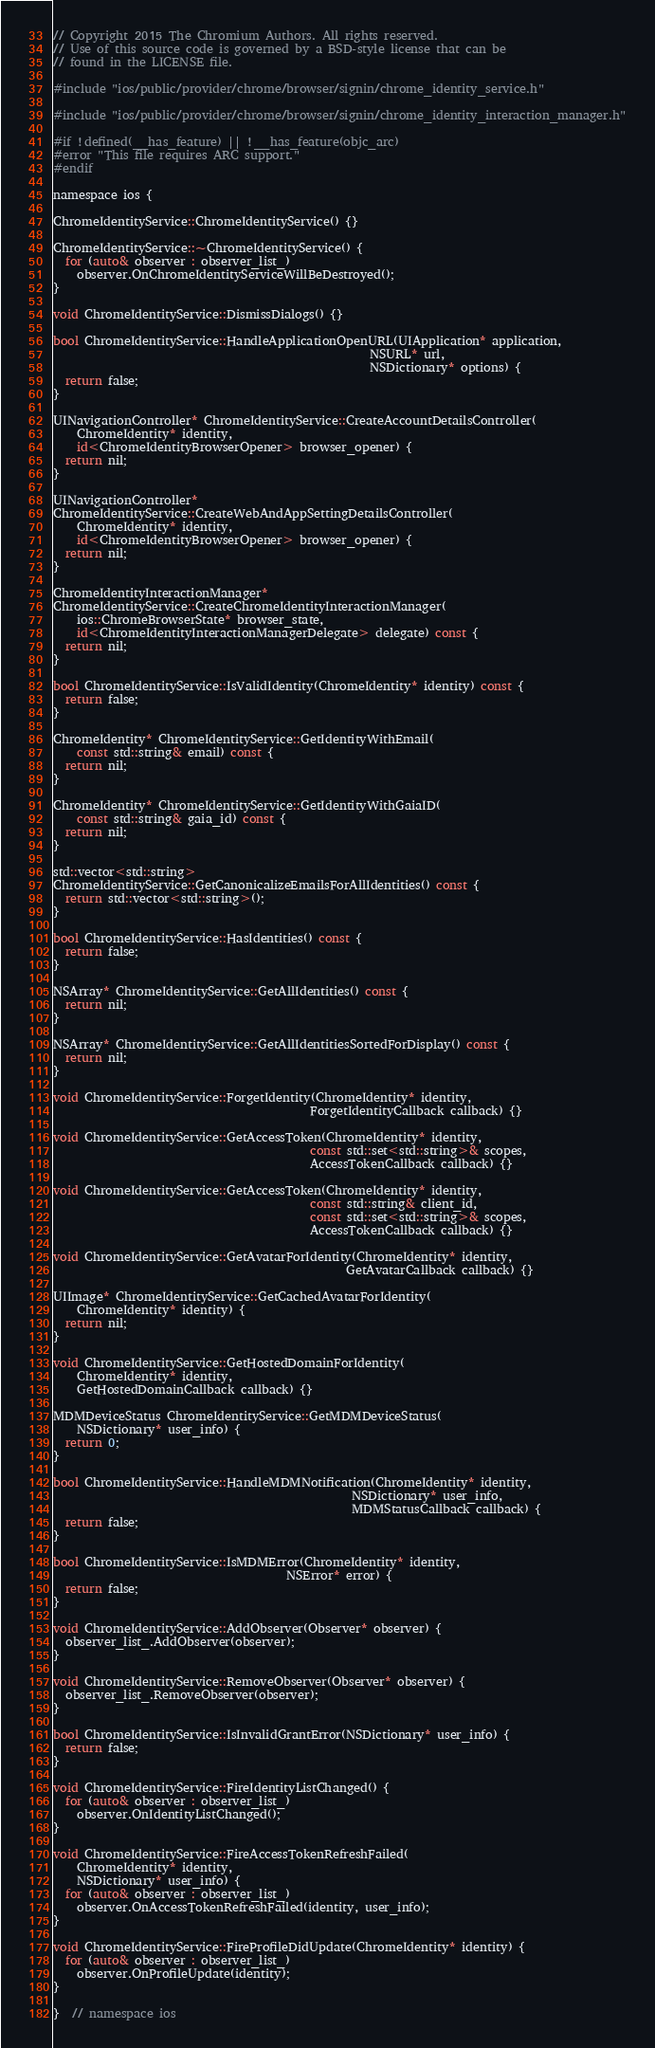Convert code to text. <code><loc_0><loc_0><loc_500><loc_500><_ObjectiveC_>// Copyright 2015 The Chromium Authors. All rights reserved.
// Use of this source code is governed by a BSD-style license that can be
// found in the LICENSE file.

#include "ios/public/provider/chrome/browser/signin/chrome_identity_service.h"

#include "ios/public/provider/chrome/browser/signin/chrome_identity_interaction_manager.h"

#if !defined(__has_feature) || !__has_feature(objc_arc)
#error "This file requires ARC support."
#endif

namespace ios {

ChromeIdentityService::ChromeIdentityService() {}

ChromeIdentityService::~ChromeIdentityService() {
  for (auto& observer : observer_list_)
    observer.OnChromeIdentityServiceWillBeDestroyed();
}

void ChromeIdentityService::DismissDialogs() {}

bool ChromeIdentityService::HandleApplicationOpenURL(UIApplication* application,
                                                     NSURL* url,
                                                     NSDictionary* options) {
  return false;
}

UINavigationController* ChromeIdentityService::CreateAccountDetailsController(
    ChromeIdentity* identity,
    id<ChromeIdentityBrowserOpener> browser_opener) {
  return nil;
}

UINavigationController*
ChromeIdentityService::CreateWebAndAppSettingDetailsController(
    ChromeIdentity* identity,
    id<ChromeIdentityBrowserOpener> browser_opener) {
  return nil;
}

ChromeIdentityInteractionManager*
ChromeIdentityService::CreateChromeIdentityInteractionManager(
    ios::ChromeBrowserState* browser_state,
    id<ChromeIdentityInteractionManagerDelegate> delegate) const {
  return nil;
}

bool ChromeIdentityService::IsValidIdentity(ChromeIdentity* identity) const {
  return false;
}

ChromeIdentity* ChromeIdentityService::GetIdentityWithEmail(
    const std::string& email) const {
  return nil;
}

ChromeIdentity* ChromeIdentityService::GetIdentityWithGaiaID(
    const std::string& gaia_id) const {
  return nil;
}

std::vector<std::string>
ChromeIdentityService::GetCanonicalizeEmailsForAllIdentities() const {
  return std::vector<std::string>();
}

bool ChromeIdentityService::HasIdentities() const {
  return false;
}

NSArray* ChromeIdentityService::GetAllIdentities() const {
  return nil;
}

NSArray* ChromeIdentityService::GetAllIdentitiesSortedForDisplay() const {
  return nil;
}

void ChromeIdentityService::ForgetIdentity(ChromeIdentity* identity,
                                           ForgetIdentityCallback callback) {}

void ChromeIdentityService::GetAccessToken(ChromeIdentity* identity,
                                           const std::set<std::string>& scopes,
                                           AccessTokenCallback callback) {}

void ChromeIdentityService::GetAccessToken(ChromeIdentity* identity,
                                           const std::string& client_id,
                                           const std::set<std::string>& scopes,
                                           AccessTokenCallback callback) {}

void ChromeIdentityService::GetAvatarForIdentity(ChromeIdentity* identity,
                                                 GetAvatarCallback callback) {}

UIImage* ChromeIdentityService::GetCachedAvatarForIdentity(
    ChromeIdentity* identity) {
  return nil;
}

void ChromeIdentityService::GetHostedDomainForIdentity(
    ChromeIdentity* identity,
    GetHostedDomainCallback callback) {}

MDMDeviceStatus ChromeIdentityService::GetMDMDeviceStatus(
    NSDictionary* user_info) {
  return 0;
}

bool ChromeIdentityService::HandleMDMNotification(ChromeIdentity* identity,
                                                  NSDictionary* user_info,
                                                  MDMStatusCallback callback) {
  return false;
}

bool ChromeIdentityService::IsMDMError(ChromeIdentity* identity,
                                       NSError* error) {
  return false;
}

void ChromeIdentityService::AddObserver(Observer* observer) {
  observer_list_.AddObserver(observer);
}

void ChromeIdentityService::RemoveObserver(Observer* observer) {
  observer_list_.RemoveObserver(observer);
}

bool ChromeIdentityService::IsInvalidGrantError(NSDictionary* user_info) {
  return false;
}

void ChromeIdentityService::FireIdentityListChanged() {
  for (auto& observer : observer_list_)
    observer.OnIdentityListChanged();
}

void ChromeIdentityService::FireAccessTokenRefreshFailed(
    ChromeIdentity* identity,
    NSDictionary* user_info) {
  for (auto& observer : observer_list_)
    observer.OnAccessTokenRefreshFailed(identity, user_info);
}

void ChromeIdentityService::FireProfileDidUpdate(ChromeIdentity* identity) {
  for (auto& observer : observer_list_)
    observer.OnProfileUpdate(identity);
}

}  // namespace ios
</code> 